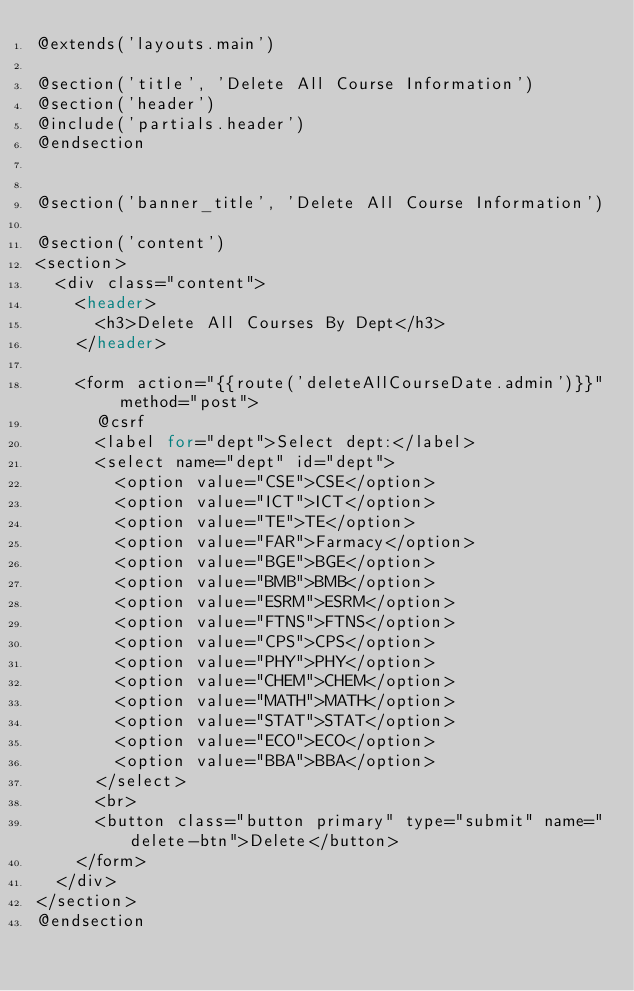Convert code to text. <code><loc_0><loc_0><loc_500><loc_500><_PHP_>@extends('layouts.main')

@section('title', 'Delete All Course Information')
@section('header')
@include('partials.header')
@endsection


@section('banner_title', 'Delete All Course Information')

@section('content')
<section>
  <div class="content">
    <header>
      <h3>Delete All Courses By Dept</h3>
    </header>

    <form action="{{route('deleteAllCourseDate.admin')}}" method="post">
      @csrf
      <label for="dept">Select dept:</label>
      <select name="dept" id="dept">
        <option value="CSE">CSE</option>
        <option value="ICT">ICT</option>
        <option value="TE">TE</option>
        <option value="FAR">Farmacy</option>
        <option value="BGE">BGE</option>
        <option value="BMB">BMB</option>
        <option value="ESRM">ESRM</option>
        <option value="FTNS">FTNS</option>
        <option value="CPS">CPS</option>
        <option value="PHY">PHY</option>
        <option value="CHEM">CHEM</option>
        <option value="MATH">MATH</option>
        <option value="STAT">STAT</option>
        <option value="ECO">ECO</option>
        <option value="BBA">BBA</option>
      </select>
      <br>
      <button class="button primary" type="submit" name="delete-btn">Delete</button>
    </form>
  </div>
</section>
@endsection</code> 